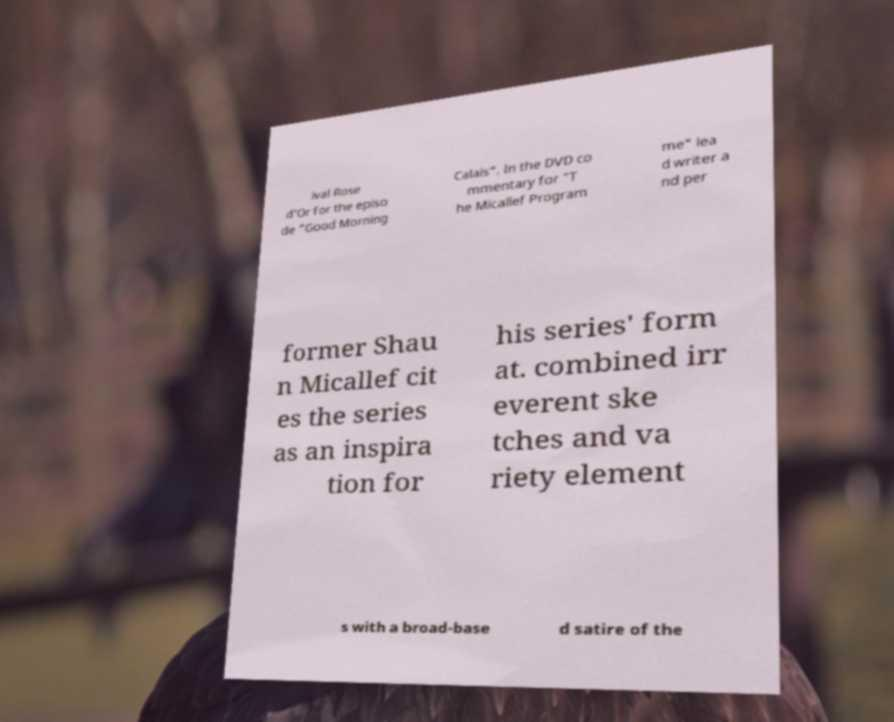Please read and relay the text visible in this image. What does it say? ival Rose d'Or for the episo de "Good Morning Calais". In the DVD co mmentary for "T he Micallef Program me" lea d writer a nd per former Shau n Micallef cit es the series as an inspira tion for his series' form at. combined irr everent ske tches and va riety element s with a broad-base d satire of the 